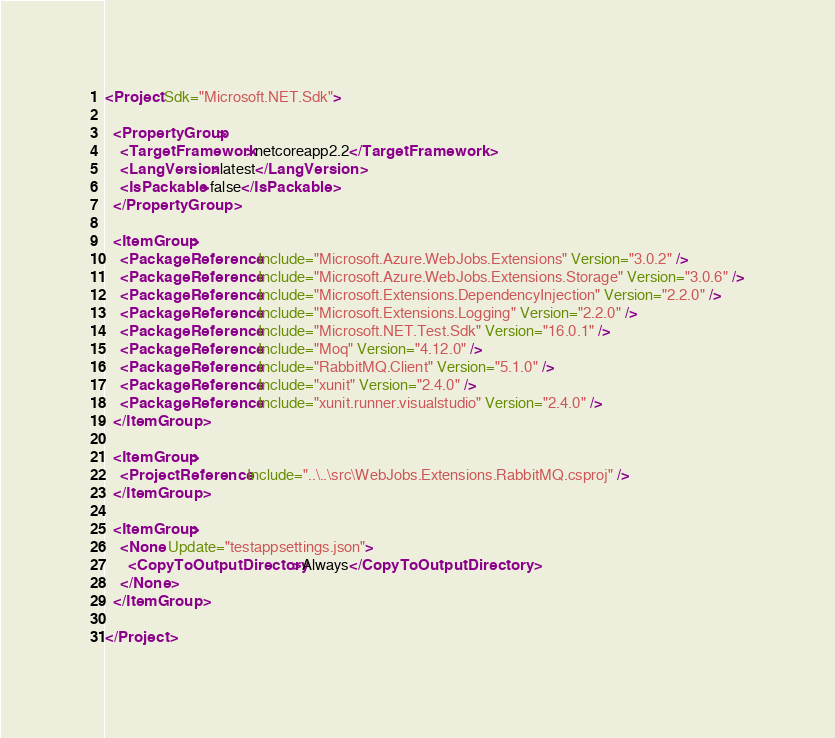<code> <loc_0><loc_0><loc_500><loc_500><_XML_><Project Sdk="Microsoft.NET.Sdk">

  <PropertyGroup>
    <TargetFramework>netcoreapp2.2</TargetFramework>
    <LangVersion>latest</LangVersion>
    <IsPackable>false</IsPackable>
  </PropertyGroup>

  <ItemGroup>
    <PackageReference Include="Microsoft.Azure.WebJobs.Extensions" Version="3.0.2" />
    <PackageReference Include="Microsoft.Azure.WebJobs.Extensions.Storage" Version="3.0.6" />
    <PackageReference Include="Microsoft.Extensions.DependencyInjection" Version="2.2.0" />
    <PackageReference Include="Microsoft.Extensions.Logging" Version="2.2.0" />
    <PackageReference Include="Microsoft.NET.Test.Sdk" Version="16.0.1" />
    <PackageReference Include="Moq" Version="4.12.0" />
    <PackageReference Include="RabbitMQ.Client" Version="5.1.0" />
    <PackageReference Include="xunit" Version="2.4.0" />
    <PackageReference Include="xunit.runner.visualstudio" Version="2.4.0" />
  </ItemGroup>

  <ItemGroup>
    <ProjectReference Include="..\..\src\WebJobs.Extensions.RabbitMQ.csproj" />
  </ItemGroup>

  <ItemGroup>
    <None Update="testappsettings.json">
      <CopyToOutputDirectory>Always</CopyToOutputDirectory>
    </None>
  </ItemGroup>

</Project>
</code> 